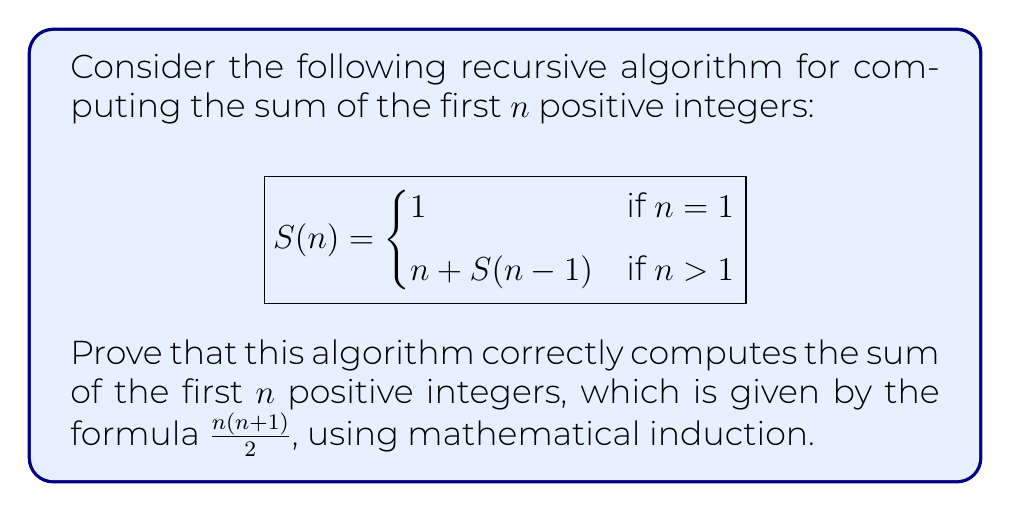Give your solution to this math problem. To prove the correctness of this recursive algorithm using mathematical induction, we need to show that $S(n) = \frac{n(n+1)}{2}$ for all positive integers n. Let's proceed step by step:

1. Base case: For n = 1
   $S(1) = 1$ (according to the algorithm)
   $\frac{1(1+1)}{2} = 1$ (the formula)
   Thus, the base case holds.

2. Inductive hypothesis: Assume that the statement is true for some positive integer k. That is:
   $S(k) = \frac{k(k+1)}{2}$

3. Inductive step: We need to prove that the statement is true for k+1:
   $S(k+1) = (k+1) + S(k)$ (according to the algorithm)
   
   Substituting the inductive hypothesis:
   $S(k+1) = (k+1) + \frac{k(k+1)}{2}$
   
   $= \frac{2(k+1)}{2} + \frac{k(k+1)}{2}$
   
   $= \frac{2(k+1) + k(k+1)}{2}$
   
   $= \frac{(k+1)(k+2)}{2}$
   
   This is exactly the formula for the sum of the first (k+1) positive integers.

4. Conclusion: By the principle of mathematical induction, we have proved that $S(n) = \frac{n(n+1)}{2}$ for all positive integers n.

Therefore, the recursive algorithm correctly computes the sum of the first n positive integers.
Answer: The algorithm is correct for all positive integers n, as $S(n) = \frac{n(n+1)}{2}$. 